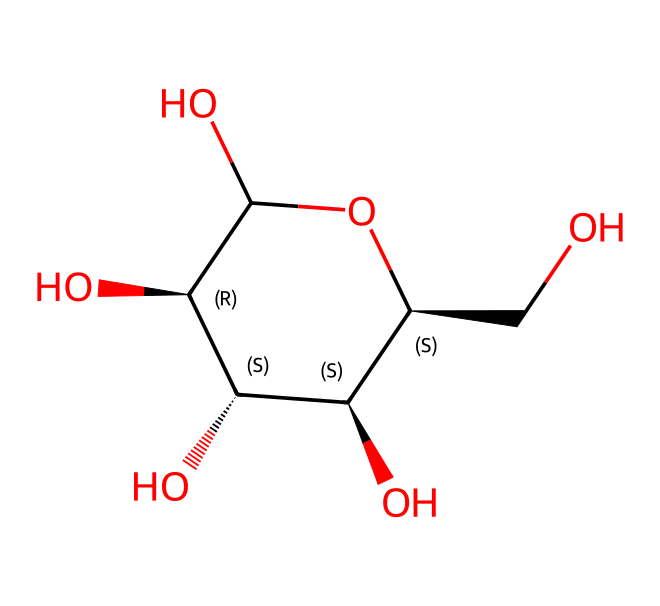How many carbon atoms are present in the structure? By examining the SMILES representation, each "C" represents a carbon atom. Counting the C's in the structure gives a total of six carbon atoms.
Answer: six What is the name of this carbohydrate? The SMILES structure corresponds to glucose, which is a simple sugar and a crucial carbohydrate.
Answer: glucose How many hydroxyl (OH) groups are in glucose? Each -OH group can be identified in the structure. There are five -OH groups shown (one for each of the hydroxyls).
Answer: five Which part of the structure indicates it is a cyclic compound? The part of the structure that includes the ring formed between the carbon atoms indicates it is a cyclic compound. This is noted by the cycle closure notation in the SMILES text (indicated by the numbers).
Answer: the ring formed by carbon atoms What type of carbohydrate is glucose categorized as? Glucose is classified as a monosaccharide, which is a single sugar unit. The presence of only one ring and no linked sugar units supports this classification.
Answer: monosaccharide What is the total number of hydrogen atoms in glucose? Each carbon and oxygen has associated hydrogen atoms. For glucose, totaling the number of hydrogen atoms gives twelve (C6H12O6).
Answer: twelve How can we determine the presence of stereochemistry in this structure? The presence of "@" symbols in the SMILES indicates the chiral centers in the glucose molecule; thus, there are four chiral centers that denote its stereochemistry.
Answer: four chiral centers 